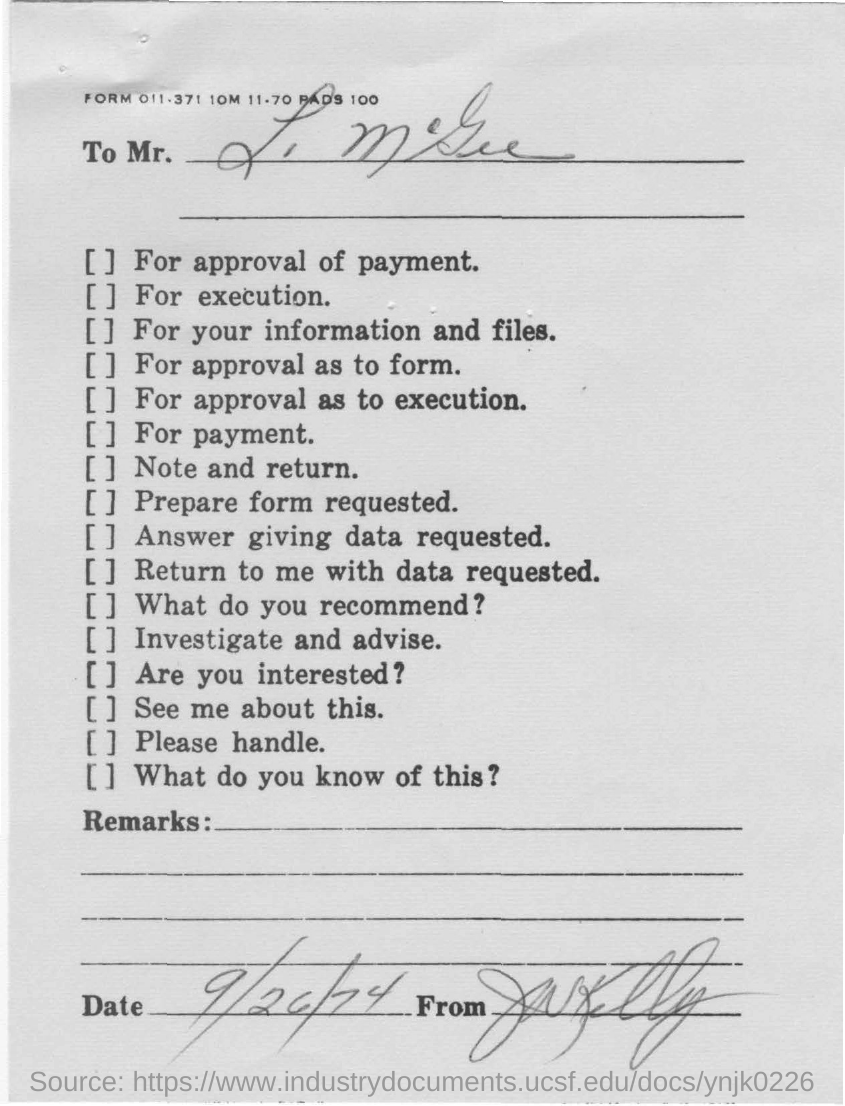Mention a couple of crucial points in this snapshot. The date given is September 26th, 1974. 